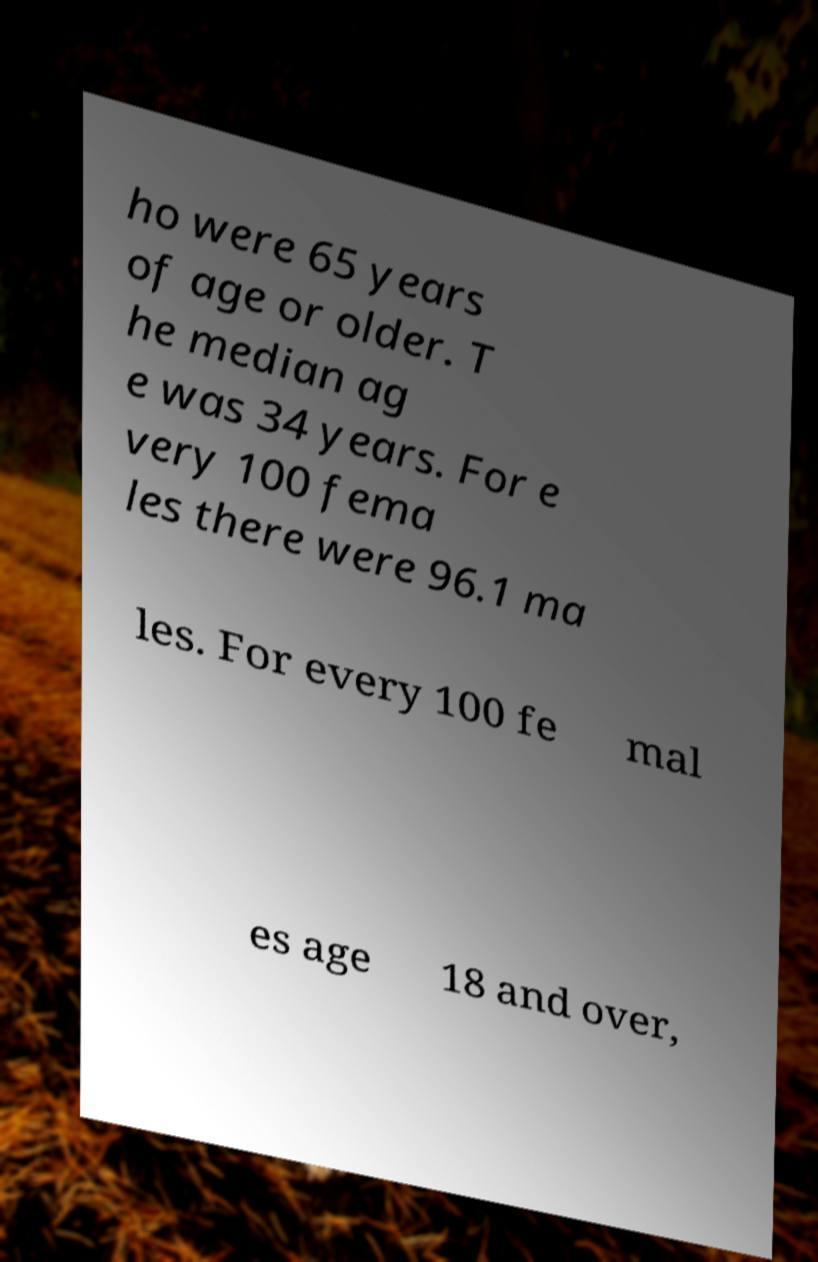Could you assist in decoding the text presented in this image and type it out clearly? ho were 65 years of age or older. T he median ag e was 34 years. For e very 100 fema les there were 96.1 ma les. For every 100 fe mal es age 18 and over, 